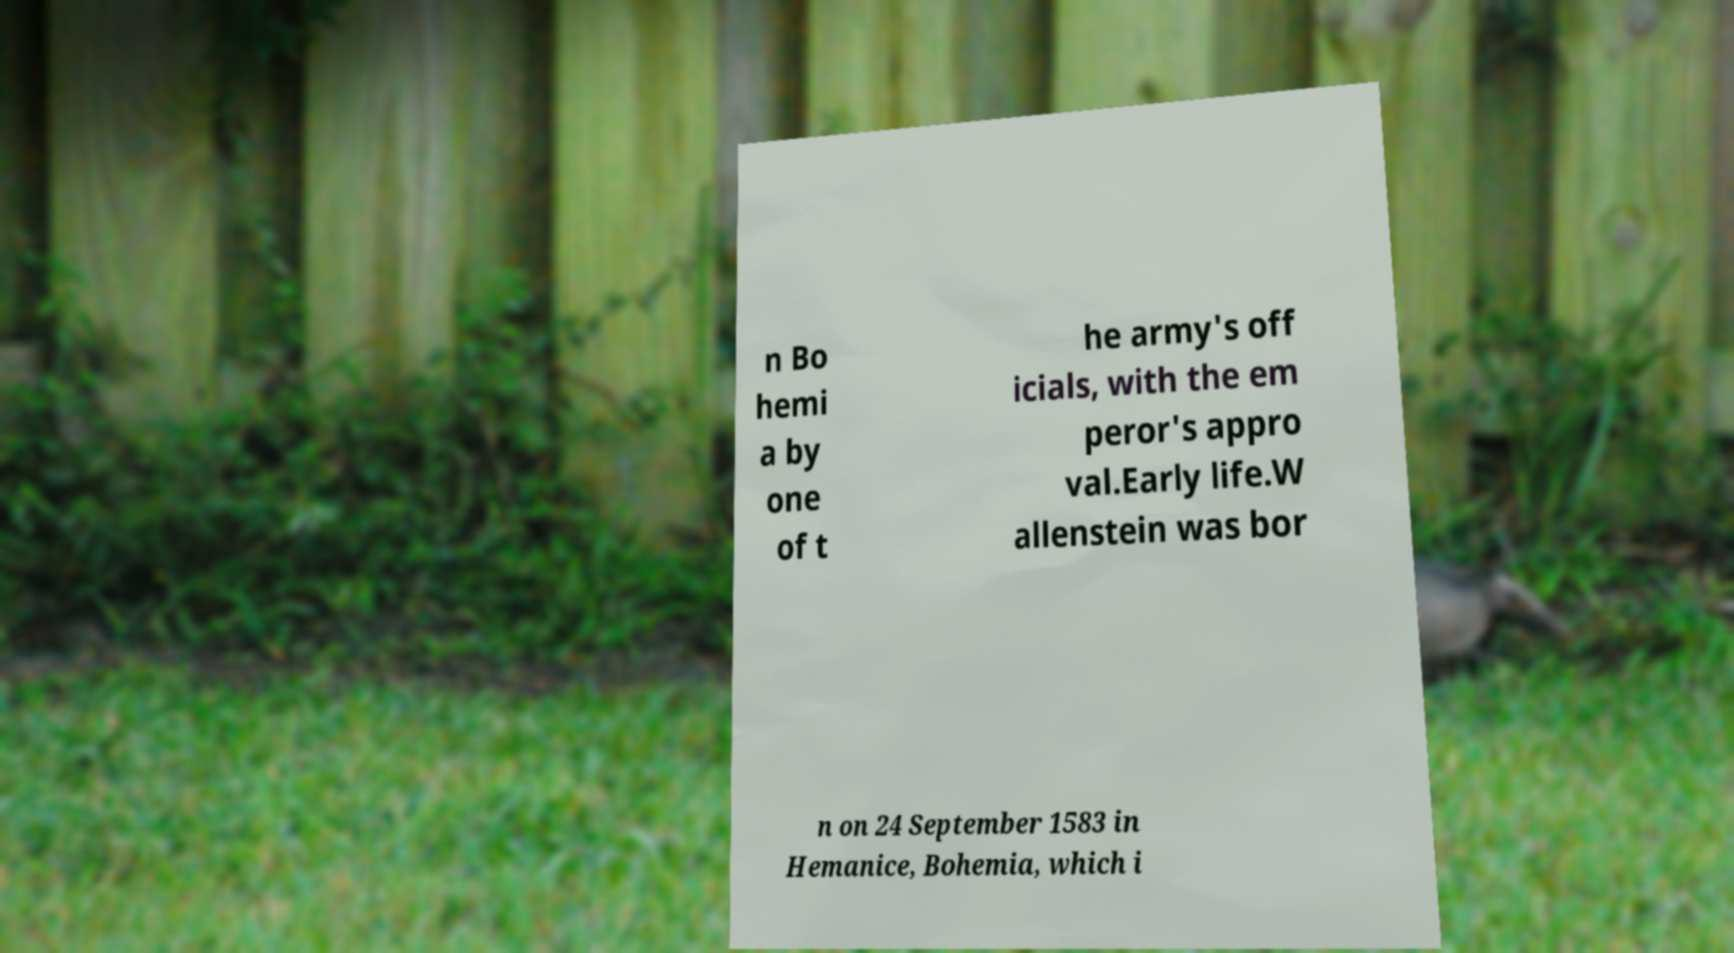There's text embedded in this image that I need extracted. Can you transcribe it verbatim? n Bo hemi a by one of t he army's off icials, with the em peror's appro val.Early life.W allenstein was bor n on 24 September 1583 in Hemanice, Bohemia, which i 